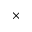<formula> <loc_0><loc_0><loc_500><loc_500>\times</formula> 